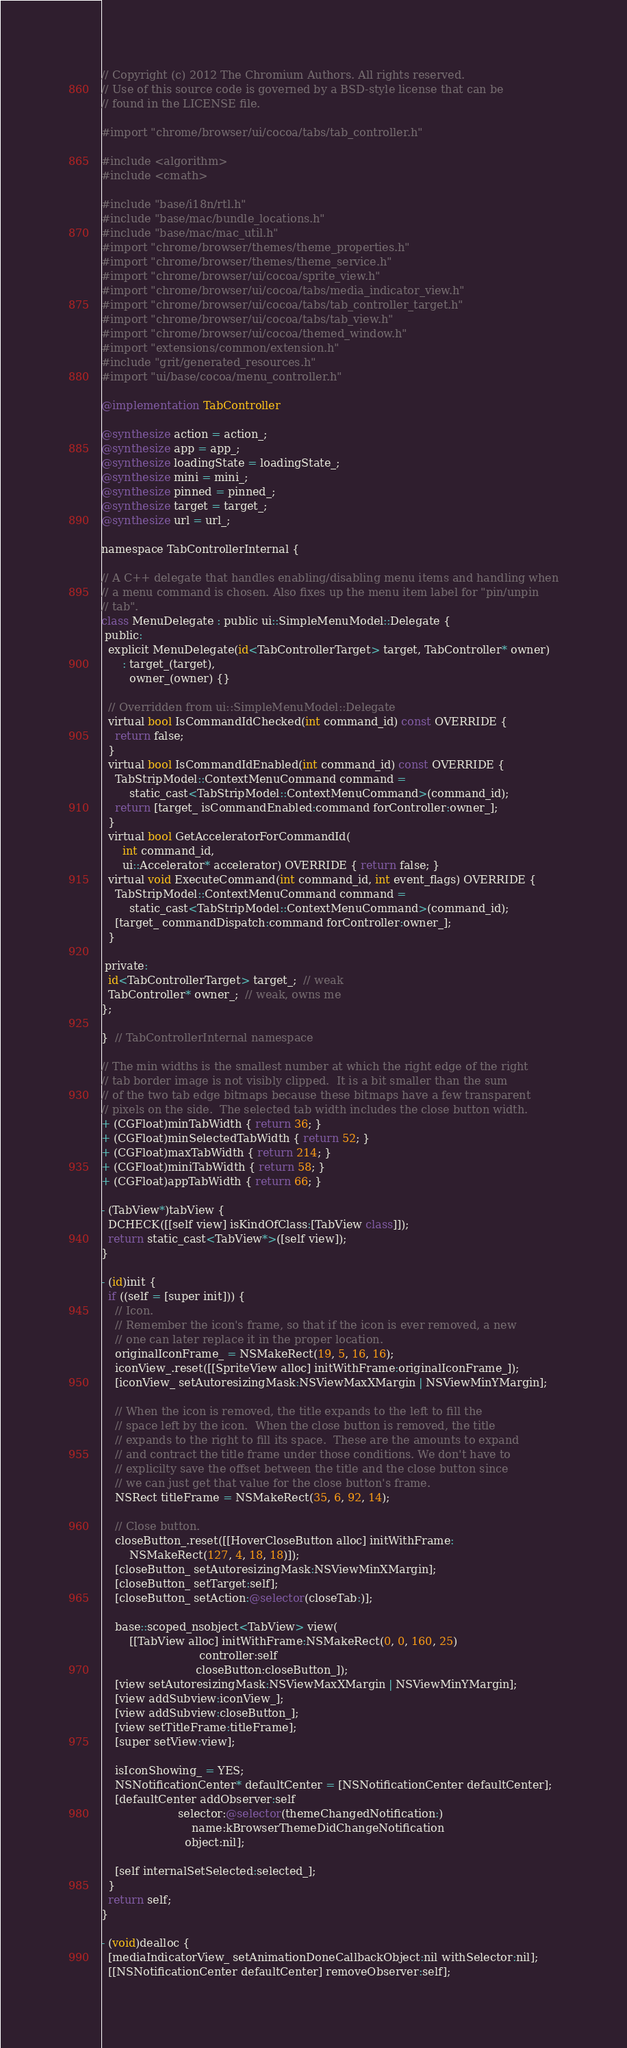<code> <loc_0><loc_0><loc_500><loc_500><_ObjectiveC_>// Copyright (c) 2012 The Chromium Authors. All rights reserved.
// Use of this source code is governed by a BSD-style license that can be
// found in the LICENSE file.

#import "chrome/browser/ui/cocoa/tabs/tab_controller.h"

#include <algorithm>
#include <cmath>

#include "base/i18n/rtl.h"
#include "base/mac/bundle_locations.h"
#include "base/mac/mac_util.h"
#import "chrome/browser/themes/theme_properties.h"
#import "chrome/browser/themes/theme_service.h"
#import "chrome/browser/ui/cocoa/sprite_view.h"
#import "chrome/browser/ui/cocoa/tabs/media_indicator_view.h"
#import "chrome/browser/ui/cocoa/tabs/tab_controller_target.h"
#import "chrome/browser/ui/cocoa/tabs/tab_view.h"
#import "chrome/browser/ui/cocoa/themed_window.h"
#import "extensions/common/extension.h"
#include "grit/generated_resources.h"
#import "ui/base/cocoa/menu_controller.h"

@implementation TabController

@synthesize action = action_;
@synthesize app = app_;
@synthesize loadingState = loadingState_;
@synthesize mini = mini_;
@synthesize pinned = pinned_;
@synthesize target = target_;
@synthesize url = url_;

namespace TabControllerInternal {

// A C++ delegate that handles enabling/disabling menu items and handling when
// a menu command is chosen. Also fixes up the menu item label for "pin/unpin
// tab".
class MenuDelegate : public ui::SimpleMenuModel::Delegate {
 public:
  explicit MenuDelegate(id<TabControllerTarget> target, TabController* owner)
      : target_(target),
        owner_(owner) {}

  // Overridden from ui::SimpleMenuModel::Delegate
  virtual bool IsCommandIdChecked(int command_id) const OVERRIDE {
    return false;
  }
  virtual bool IsCommandIdEnabled(int command_id) const OVERRIDE {
    TabStripModel::ContextMenuCommand command =
        static_cast<TabStripModel::ContextMenuCommand>(command_id);
    return [target_ isCommandEnabled:command forController:owner_];
  }
  virtual bool GetAcceleratorForCommandId(
      int command_id,
      ui::Accelerator* accelerator) OVERRIDE { return false; }
  virtual void ExecuteCommand(int command_id, int event_flags) OVERRIDE {
    TabStripModel::ContextMenuCommand command =
        static_cast<TabStripModel::ContextMenuCommand>(command_id);
    [target_ commandDispatch:command forController:owner_];
  }

 private:
  id<TabControllerTarget> target_;  // weak
  TabController* owner_;  // weak, owns me
};

}  // TabControllerInternal namespace

// The min widths is the smallest number at which the right edge of the right
// tab border image is not visibly clipped.  It is a bit smaller than the sum
// of the two tab edge bitmaps because these bitmaps have a few transparent
// pixels on the side.  The selected tab width includes the close button width.
+ (CGFloat)minTabWidth { return 36; }
+ (CGFloat)minSelectedTabWidth { return 52; }
+ (CGFloat)maxTabWidth { return 214; }
+ (CGFloat)miniTabWidth { return 58; }
+ (CGFloat)appTabWidth { return 66; }

- (TabView*)tabView {
  DCHECK([[self view] isKindOfClass:[TabView class]]);
  return static_cast<TabView*>([self view]);
}

- (id)init {
  if ((self = [super init])) {
    // Icon.
    // Remember the icon's frame, so that if the icon is ever removed, a new
    // one can later replace it in the proper location.
    originalIconFrame_ = NSMakeRect(19, 5, 16, 16);
    iconView_.reset([[SpriteView alloc] initWithFrame:originalIconFrame_]);
    [iconView_ setAutoresizingMask:NSViewMaxXMargin | NSViewMinYMargin];

    // When the icon is removed, the title expands to the left to fill the
    // space left by the icon.  When the close button is removed, the title
    // expands to the right to fill its space.  These are the amounts to expand
    // and contract the title frame under those conditions. We don't have to
    // explicilty save the offset between the title and the close button since
    // we can just get that value for the close button's frame.
    NSRect titleFrame = NSMakeRect(35, 6, 92, 14);

    // Close button.
    closeButton_.reset([[HoverCloseButton alloc] initWithFrame:
        NSMakeRect(127, 4, 18, 18)]);
    [closeButton_ setAutoresizingMask:NSViewMinXMargin];
    [closeButton_ setTarget:self];
    [closeButton_ setAction:@selector(closeTab:)];

    base::scoped_nsobject<TabView> view(
        [[TabView alloc] initWithFrame:NSMakeRect(0, 0, 160, 25)
                            controller:self
                           closeButton:closeButton_]);
    [view setAutoresizingMask:NSViewMaxXMargin | NSViewMinYMargin];
    [view addSubview:iconView_];
    [view addSubview:closeButton_];
    [view setTitleFrame:titleFrame];
    [super setView:view];

    isIconShowing_ = YES;
    NSNotificationCenter* defaultCenter = [NSNotificationCenter defaultCenter];
    [defaultCenter addObserver:self
                      selector:@selector(themeChangedNotification:)
                          name:kBrowserThemeDidChangeNotification
                        object:nil];

    [self internalSetSelected:selected_];
  }
  return self;
}

- (void)dealloc {
  [mediaIndicatorView_ setAnimationDoneCallbackObject:nil withSelector:nil];
  [[NSNotificationCenter defaultCenter] removeObserver:self];</code> 